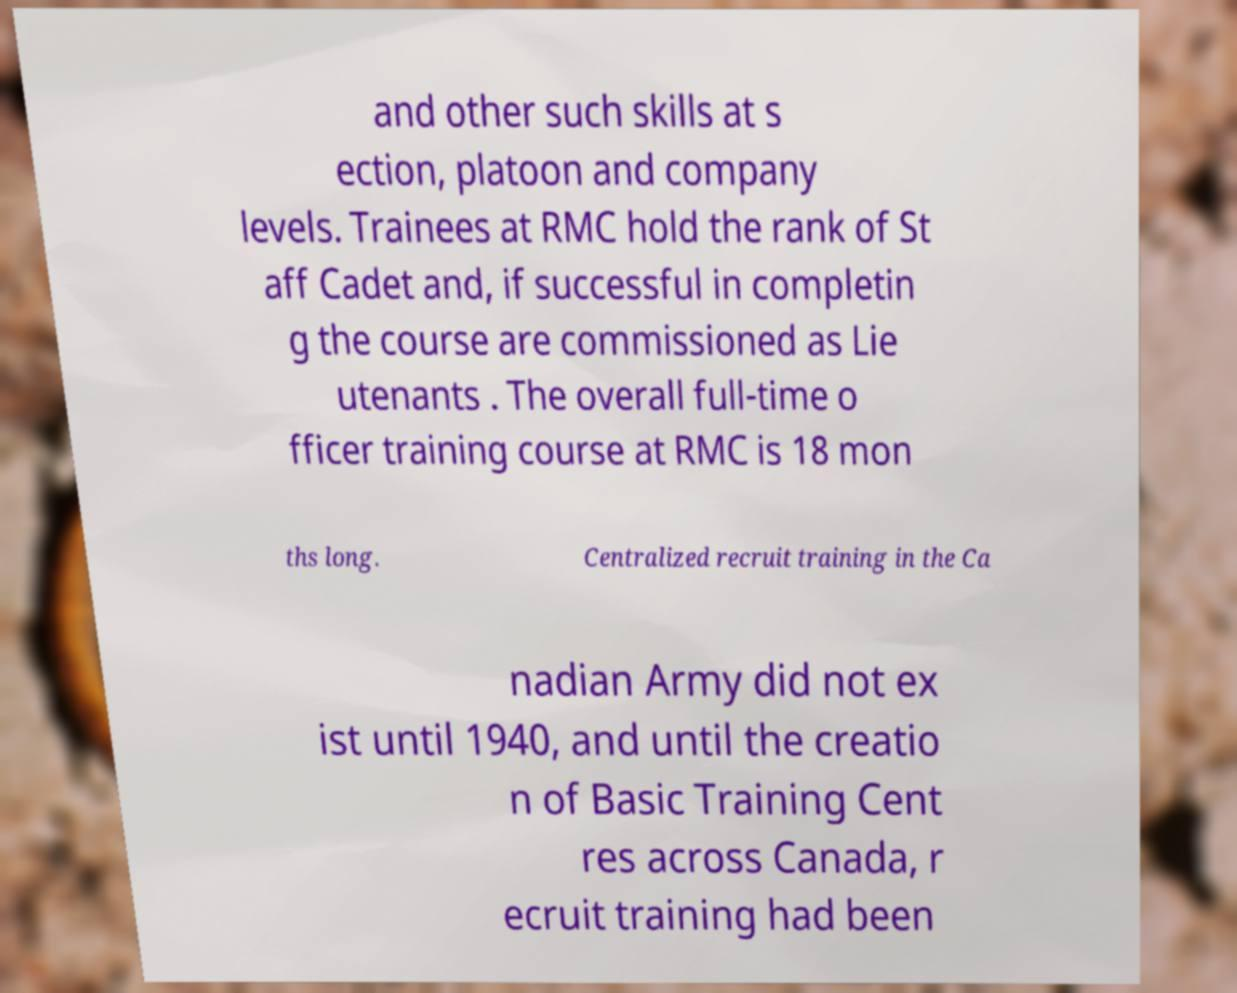Could you extract and type out the text from this image? and other such skills at s ection, platoon and company levels. Trainees at RMC hold the rank of St aff Cadet and, if successful in completin g the course are commissioned as Lie utenants . The overall full-time o fficer training course at RMC is 18 mon ths long. Centralized recruit training in the Ca nadian Army did not ex ist until 1940, and until the creatio n of Basic Training Cent res across Canada, r ecruit training had been 